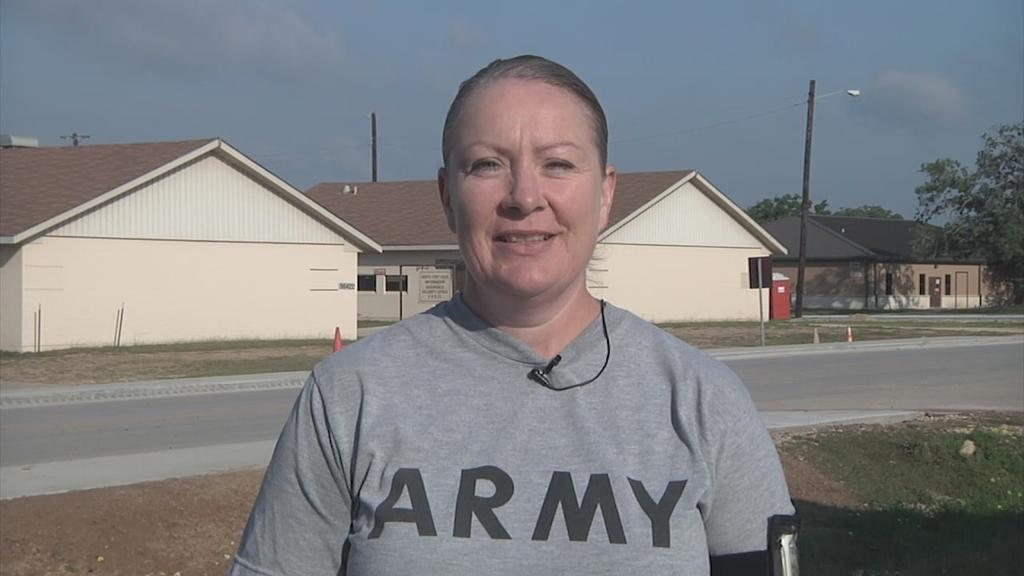What is the person in the image doing? The person is smiling in the image. What can be seen in the background of the image? There is a road, cone barricades, houses, trees, and the sky visible in the background of the image. How many pizzas are being delivered to the island in the image? There is no island or pizzas present in the image. 